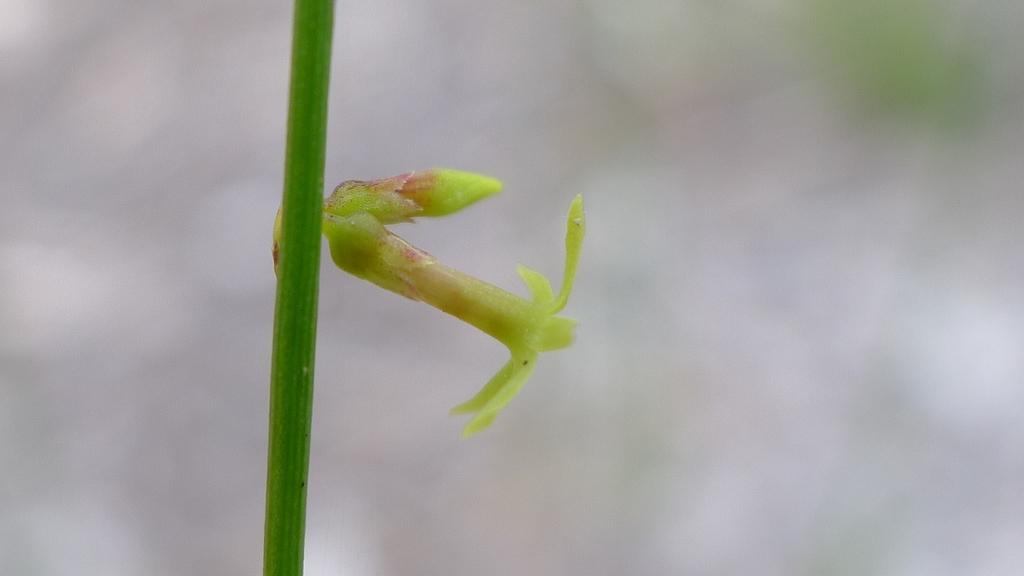What can be seen in the image related to a plant? There is a plant stem in the image. What stage of growth are the plant's buds in? The plant stem has buds. How would you describe the background of the image? The background of the image is blurred. Where is the ball located in the image? There is no ball present in the image. What type of food is being served in the lunchroom in the image? There is no lunchroom present in the image. 